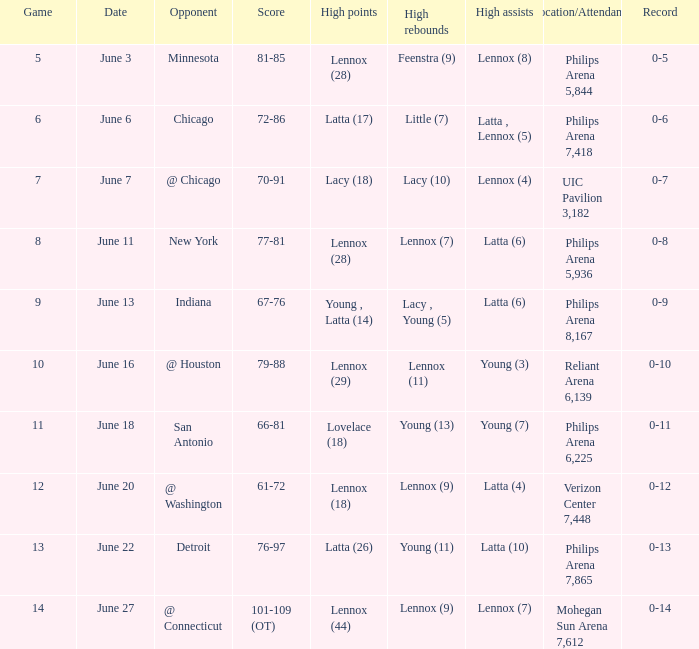Would you be able to parse every entry in this table? {'header': ['Game', 'Date', 'Opponent', 'Score', 'High points', 'High rebounds', 'High assists', 'Location/Attendance', 'Record'], 'rows': [['5', 'June 3', 'Minnesota', '81-85', 'Lennox (28)', 'Feenstra (9)', 'Lennox (8)', 'Philips Arena 5,844', '0-5'], ['6', 'June 6', 'Chicago', '72-86', 'Latta (17)', 'Little (7)', 'Latta , Lennox (5)', 'Philips Arena 7,418', '0-6'], ['7', 'June 7', '@ Chicago', '70-91', 'Lacy (18)', 'Lacy (10)', 'Lennox (4)', 'UIC Pavilion 3,182', '0-7'], ['8', 'June 11', 'New York', '77-81', 'Lennox (28)', 'Lennox (7)', 'Latta (6)', 'Philips Arena 5,936', '0-8'], ['9', 'June 13', 'Indiana', '67-76', 'Young , Latta (14)', 'Lacy , Young (5)', 'Latta (6)', 'Philips Arena 8,167', '0-9'], ['10', 'June 16', '@ Houston', '79-88', 'Lennox (29)', 'Lennox (11)', 'Young (3)', 'Reliant Arena 6,139', '0-10'], ['11', 'June 18', 'San Antonio', '66-81', 'Lovelace (18)', 'Young (13)', 'Young (7)', 'Philips Arena 6,225', '0-11'], ['12', 'June 20', '@ Washington', '61-72', 'Lennox (18)', 'Lennox (9)', 'Latta (4)', 'Verizon Center 7,448', '0-12'], ['13', 'June 22', 'Detroit', '76-97', 'Latta (26)', 'Young (11)', 'Latta (10)', 'Philips Arena 7,865', '0-13'], ['14', 'June 27', '@ Connecticut', '101-109 (OT)', 'Lennox (44)', 'Lennox (9)', 'Lennox (7)', 'Mohegan Sun Arena 7,612', '0-14']]} At which stadium did the june 7 match take place and how many spectators were present? UIC Pavilion 3,182. 